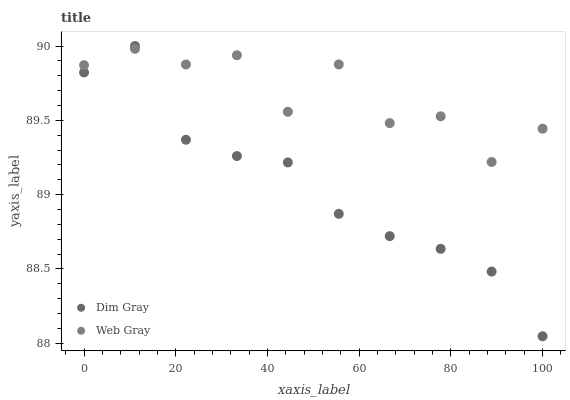Does Dim Gray have the minimum area under the curve?
Answer yes or no. Yes. Does Web Gray have the maximum area under the curve?
Answer yes or no. Yes. Does Web Gray have the minimum area under the curve?
Answer yes or no. No. Is Dim Gray the smoothest?
Answer yes or no. Yes. Is Web Gray the roughest?
Answer yes or no. Yes. Is Web Gray the smoothest?
Answer yes or no. No. Does Dim Gray have the lowest value?
Answer yes or no. Yes. Does Web Gray have the lowest value?
Answer yes or no. No. Does Dim Gray have the highest value?
Answer yes or no. Yes. Does Web Gray have the highest value?
Answer yes or no. No. Does Web Gray intersect Dim Gray?
Answer yes or no. Yes. Is Web Gray less than Dim Gray?
Answer yes or no. No. Is Web Gray greater than Dim Gray?
Answer yes or no. No. 